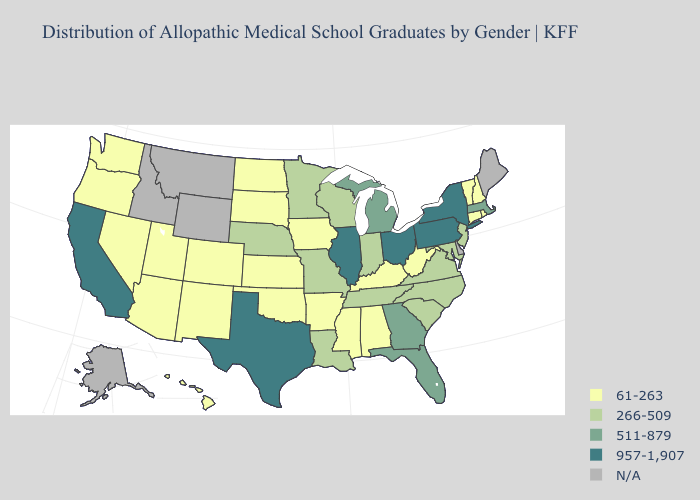What is the lowest value in the USA?
Write a very short answer. 61-263. Is the legend a continuous bar?
Concise answer only. No. Does Tennessee have the lowest value in the South?
Quick response, please. No. What is the lowest value in states that border Indiana?
Answer briefly. 61-263. What is the value of Georgia?
Give a very brief answer. 511-879. What is the value of Illinois?
Give a very brief answer. 957-1,907. What is the value of Colorado?
Answer briefly. 61-263. Name the states that have a value in the range 511-879?
Answer briefly. Florida, Georgia, Massachusetts, Michigan. Which states hav the highest value in the MidWest?
Short answer required. Illinois, Ohio. What is the value of Indiana?
Be succinct. 266-509. What is the value of Indiana?
Write a very short answer. 266-509. What is the lowest value in states that border Minnesota?
Be succinct. 61-263. What is the lowest value in states that border Maine?
Quick response, please. 61-263. What is the value of Idaho?
Be succinct. N/A. Which states hav the highest value in the MidWest?
Quick response, please. Illinois, Ohio. 